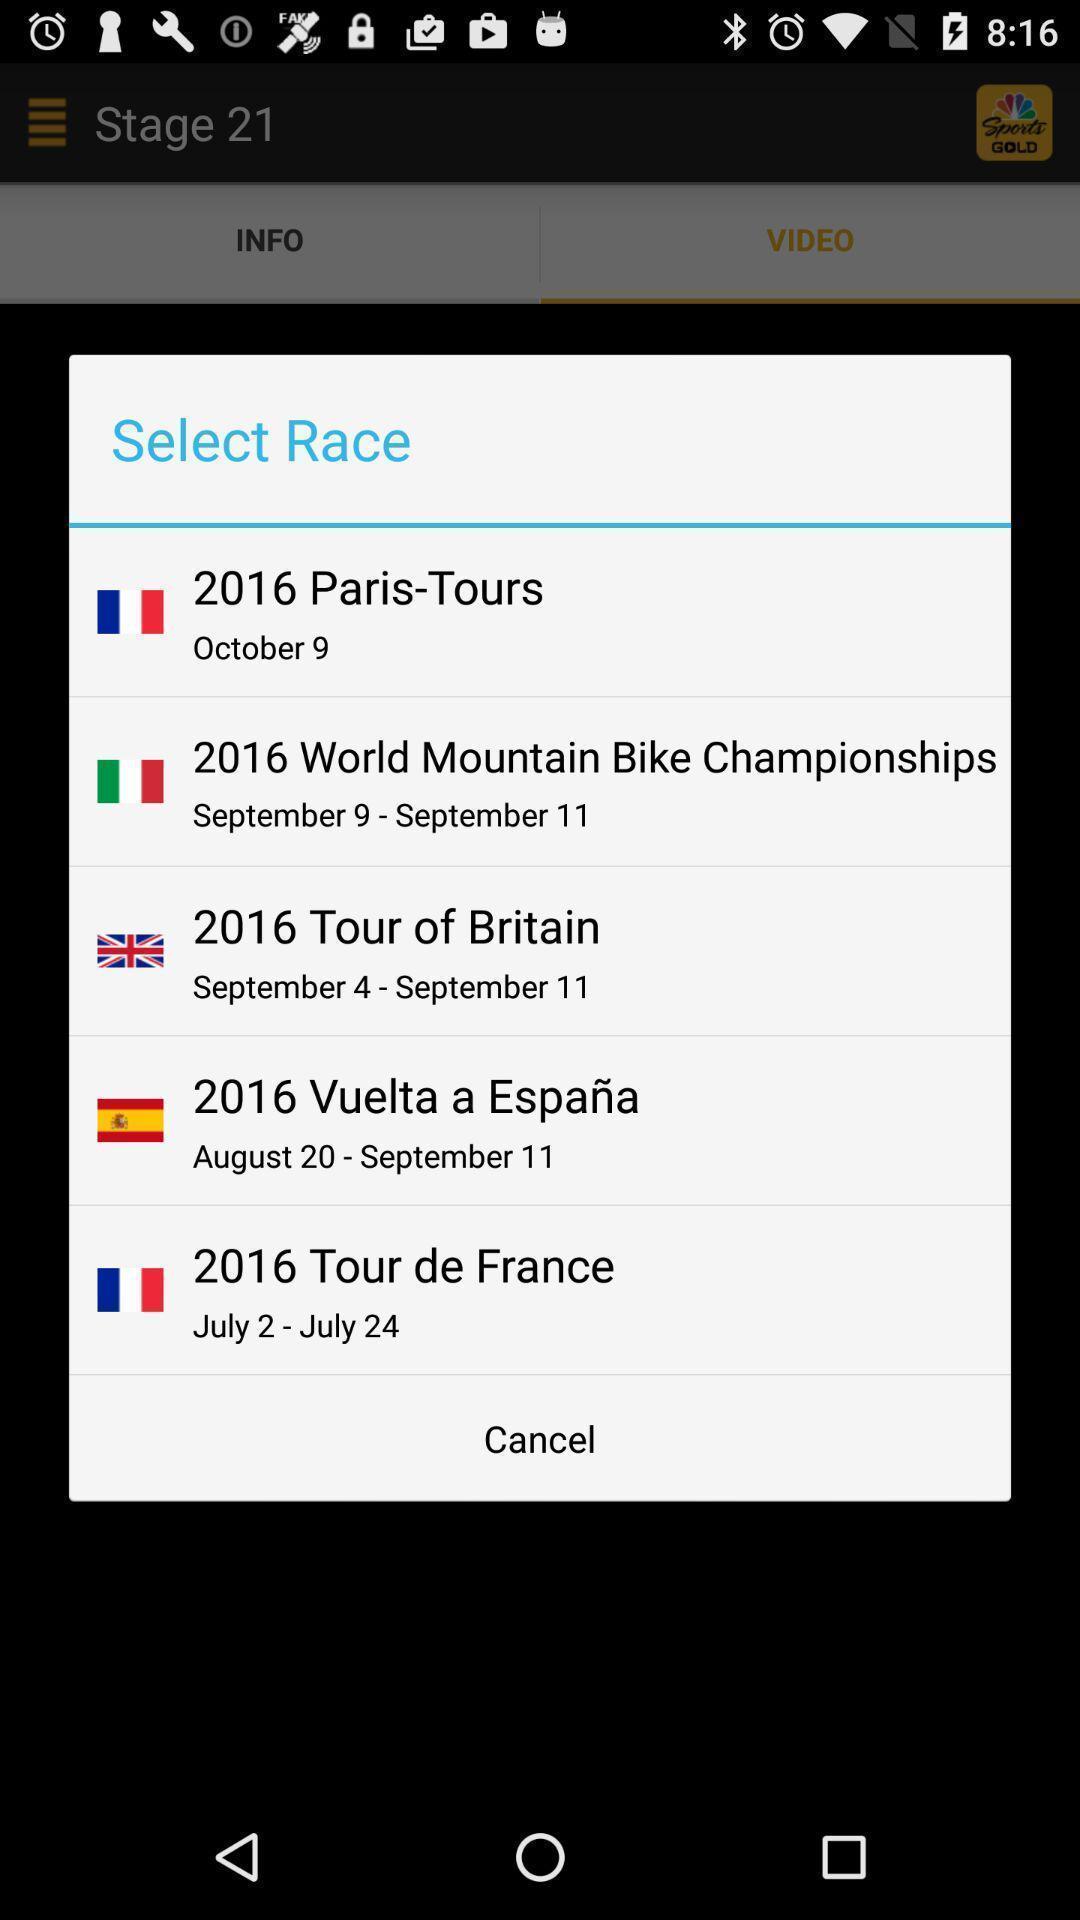Give me a narrative description of this picture. Pop-up to select a race on sports app. 